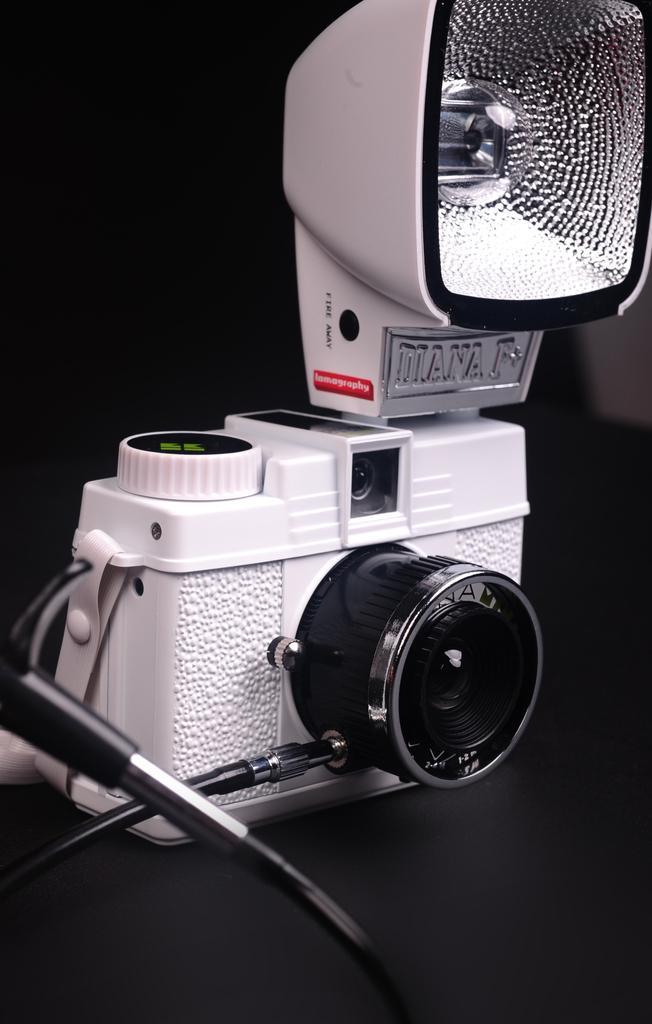Describe this image in one or two sentences. In this picture we can see a camera and dark background. 